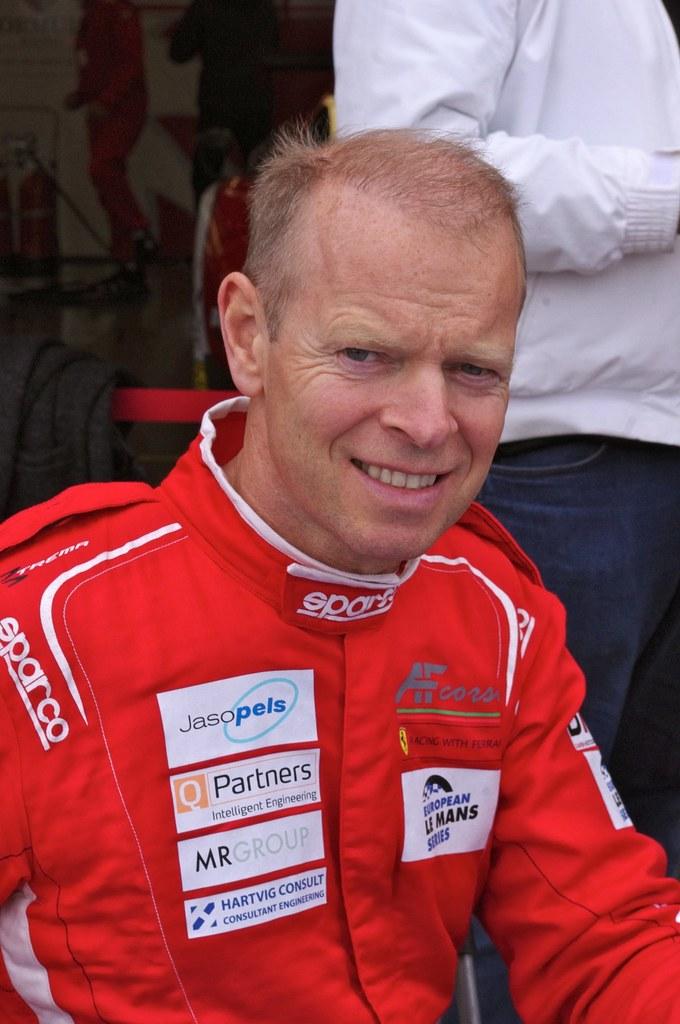Who is the first sponsor on this man's jacket?
Provide a succinct answer. Jasopels. 